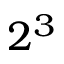Convert formula to latex. <formula><loc_0><loc_0><loc_500><loc_500>2 ^ { 3 }</formula> 